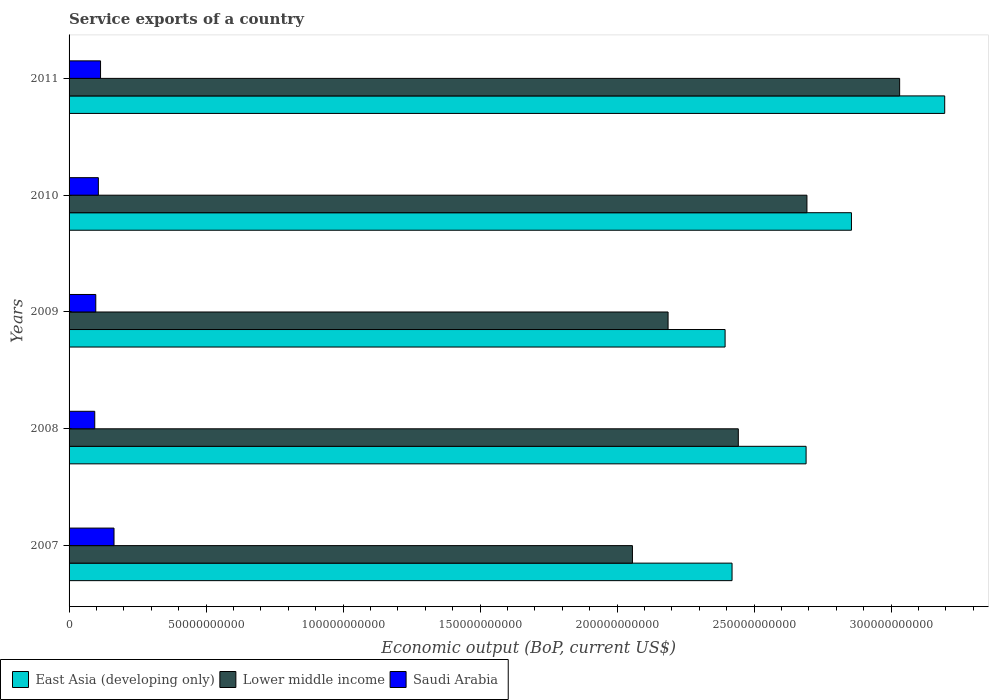How many different coloured bars are there?
Keep it short and to the point. 3. How many groups of bars are there?
Provide a succinct answer. 5. Are the number of bars per tick equal to the number of legend labels?
Offer a very short reply. Yes. How many bars are there on the 2nd tick from the top?
Your answer should be very brief. 3. How many bars are there on the 5th tick from the bottom?
Ensure brevity in your answer.  3. In how many cases, is the number of bars for a given year not equal to the number of legend labels?
Make the answer very short. 0. What is the service exports in East Asia (developing only) in 2008?
Make the answer very short. 2.69e+11. Across all years, what is the maximum service exports in Saudi Arabia?
Offer a very short reply. 1.64e+1. Across all years, what is the minimum service exports in Lower middle income?
Provide a short and direct response. 2.06e+11. In which year was the service exports in Lower middle income maximum?
Offer a very short reply. 2011. In which year was the service exports in Lower middle income minimum?
Your response must be concise. 2007. What is the total service exports in Lower middle income in the graph?
Offer a terse response. 1.24e+12. What is the difference between the service exports in East Asia (developing only) in 2008 and that in 2010?
Your answer should be very brief. -1.66e+1. What is the difference between the service exports in Saudi Arabia in 2008 and the service exports in East Asia (developing only) in 2007?
Make the answer very short. -2.33e+11. What is the average service exports in East Asia (developing only) per year?
Provide a succinct answer. 2.71e+11. In the year 2009, what is the difference between the service exports in East Asia (developing only) and service exports in Lower middle income?
Make the answer very short. 2.08e+1. In how many years, is the service exports in East Asia (developing only) greater than 300000000000 US$?
Keep it short and to the point. 1. What is the ratio of the service exports in Saudi Arabia in 2010 to that in 2011?
Your answer should be compact. 0.93. Is the service exports in East Asia (developing only) in 2007 less than that in 2010?
Your answer should be compact. Yes. What is the difference between the highest and the second highest service exports in East Asia (developing only)?
Offer a terse response. 3.40e+1. What is the difference between the highest and the lowest service exports in East Asia (developing only)?
Provide a short and direct response. 8.02e+1. What does the 3rd bar from the top in 2008 represents?
Provide a short and direct response. East Asia (developing only). What does the 1st bar from the bottom in 2008 represents?
Your response must be concise. East Asia (developing only). Is it the case that in every year, the sum of the service exports in Saudi Arabia and service exports in Lower middle income is greater than the service exports in East Asia (developing only)?
Give a very brief answer. No. How many bars are there?
Give a very brief answer. 15. How many years are there in the graph?
Provide a short and direct response. 5. Does the graph contain any zero values?
Give a very brief answer. No. Does the graph contain grids?
Your answer should be compact. No. Where does the legend appear in the graph?
Offer a very short reply. Bottom left. How are the legend labels stacked?
Keep it short and to the point. Horizontal. What is the title of the graph?
Provide a succinct answer. Service exports of a country. Does "Peru" appear as one of the legend labels in the graph?
Make the answer very short. No. What is the label or title of the X-axis?
Your answer should be very brief. Economic output (BoP, current US$). What is the label or title of the Y-axis?
Ensure brevity in your answer.  Years. What is the Economic output (BoP, current US$) in East Asia (developing only) in 2007?
Ensure brevity in your answer.  2.42e+11. What is the Economic output (BoP, current US$) of Lower middle income in 2007?
Ensure brevity in your answer.  2.06e+11. What is the Economic output (BoP, current US$) in Saudi Arabia in 2007?
Provide a short and direct response. 1.64e+1. What is the Economic output (BoP, current US$) in East Asia (developing only) in 2008?
Make the answer very short. 2.69e+11. What is the Economic output (BoP, current US$) in Lower middle income in 2008?
Your answer should be very brief. 2.44e+11. What is the Economic output (BoP, current US$) of Saudi Arabia in 2008?
Make the answer very short. 9.37e+09. What is the Economic output (BoP, current US$) of East Asia (developing only) in 2009?
Make the answer very short. 2.39e+11. What is the Economic output (BoP, current US$) of Lower middle income in 2009?
Ensure brevity in your answer.  2.19e+11. What is the Economic output (BoP, current US$) of Saudi Arabia in 2009?
Offer a very short reply. 9.75e+09. What is the Economic output (BoP, current US$) of East Asia (developing only) in 2010?
Ensure brevity in your answer.  2.86e+11. What is the Economic output (BoP, current US$) of Lower middle income in 2010?
Your response must be concise. 2.69e+11. What is the Economic output (BoP, current US$) in Saudi Arabia in 2010?
Ensure brevity in your answer.  1.07e+1. What is the Economic output (BoP, current US$) of East Asia (developing only) in 2011?
Offer a very short reply. 3.20e+11. What is the Economic output (BoP, current US$) of Lower middle income in 2011?
Give a very brief answer. 3.03e+11. What is the Economic output (BoP, current US$) of Saudi Arabia in 2011?
Offer a terse response. 1.15e+1. Across all years, what is the maximum Economic output (BoP, current US$) of East Asia (developing only)?
Ensure brevity in your answer.  3.20e+11. Across all years, what is the maximum Economic output (BoP, current US$) in Lower middle income?
Offer a very short reply. 3.03e+11. Across all years, what is the maximum Economic output (BoP, current US$) of Saudi Arabia?
Ensure brevity in your answer.  1.64e+1. Across all years, what is the minimum Economic output (BoP, current US$) of East Asia (developing only)?
Your answer should be very brief. 2.39e+11. Across all years, what is the minimum Economic output (BoP, current US$) in Lower middle income?
Keep it short and to the point. 2.06e+11. Across all years, what is the minimum Economic output (BoP, current US$) of Saudi Arabia?
Keep it short and to the point. 9.37e+09. What is the total Economic output (BoP, current US$) of East Asia (developing only) in the graph?
Provide a succinct answer. 1.36e+12. What is the total Economic output (BoP, current US$) of Lower middle income in the graph?
Keep it short and to the point. 1.24e+12. What is the total Economic output (BoP, current US$) of Saudi Arabia in the graph?
Provide a succinct answer. 5.77e+1. What is the difference between the Economic output (BoP, current US$) in East Asia (developing only) in 2007 and that in 2008?
Your answer should be very brief. -2.70e+1. What is the difference between the Economic output (BoP, current US$) in Lower middle income in 2007 and that in 2008?
Offer a very short reply. -3.86e+1. What is the difference between the Economic output (BoP, current US$) in Saudi Arabia in 2007 and that in 2008?
Your response must be concise. 7.03e+09. What is the difference between the Economic output (BoP, current US$) in East Asia (developing only) in 2007 and that in 2009?
Offer a very short reply. 2.54e+09. What is the difference between the Economic output (BoP, current US$) of Lower middle income in 2007 and that in 2009?
Ensure brevity in your answer.  -1.30e+1. What is the difference between the Economic output (BoP, current US$) in Saudi Arabia in 2007 and that in 2009?
Offer a very short reply. 6.65e+09. What is the difference between the Economic output (BoP, current US$) of East Asia (developing only) in 2007 and that in 2010?
Make the answer very short. -4.36e+1. What is the difference between the Economic output (BoP, current US$) in Lower middle income in 2007 and that in 2010?
Provide a succinct answer. -6.37e+1. What is the difference between the Economic output (BoP, current US$) in Saudi Arabia in 2007 and that in 2010?
Offer a very short reply. 5.72e+09. What is the difference between the Economic output (BoP, current US$) of East Asia (developing only) in 2007 and that in 2011?
Your response must be concise. -7.76e+1. What is the difference between the Economic output (BoP, current US$) of Lower middle income in 2007 and that in 2011?
Give a very brief answer. -9.75e+1. What is the difference between the Economic output (BoP, current US$) of Saudi Arabia in 2007 and that in 2011?
Offer a very short reply. 4.91e+09. What is the difference between the Economic output (BoP, current US$) of East Asia (developing only) in 2008 and that in 2009?
Your answer should be very brief. 2.96e+1. What is the difference between the Economic output (BoP, current US$) of Lower middle income in 2008 and that in 2009?
Provide a succinct answer. 2.56e+1. What is the difference between the Economic output (BoP, current US$) in Saudi Arabia in 2008 and that in 2009?
Provide a short and direct response. -3.76e+08. What is the difference between the Economic output (BoP, current US$) of East Asia (developing only) in 2008 and that in 2010?
Ensure brevity in your answer.  -1.66e+1. What is the difference between the Economic output (BoP, current US$) in Lower middle income in 2008 and that in 2010?
Provide a succinct answer. -2.50e+1. What is the difference between the Economic output (BoP, current US$) of Saudi Arabia in 2008 and that in 2010?
Provide a succinct answer. -1.32e+09. What is the difference between the Economic output (BoP, current US$) of East Asia (developing only) in 2008 and that in 2011?
Keep it short and to the point. -5.06e+1. What is the difference between the Economic output (BoP, current US$) of Lower middle income in 2008 and that in 2011?
Make the answer very short. -5.89e+1. What is the difference between the Economic output (BoP, current US$) in Saudi Arabia in 2008 and that in 2011?
Your answer should be compact. -2.12e+09. What is the difference between the Economic output (BoP, current US$) in East Asia (developing only) in 2009 and that in 2010?
Your answer should be very brief. -4.61e+1. What is the difference between the Economic output (BoP, current US$) in Lower middle income in 2009 and that in 2010?
Make the answer very short. -5.07e+1. What is the difference between the Economic output (BoP, current US$) in Saudi Arabia in 2009 and that in 2010?
Give a very brief answer. -9.39e+08. What is the difference between the Economic output (BoP, current US$) of East Asia (developing only) in 2009 and that in 2011?
Provide a short and direct response. -8.02e+1. What is the difference between the Economic output (BoP, current US$) of Lower middle income in 2009 and that in 2011?
Keep it short and to the point. -8.45e+1. What is the difference between the Economic output (BoP, current US$) of Saudi Arabia in 2009 and that in 2011?
Give a very brief answer. -1.74e+09. What is the difference between the Economic output (BoP, current US$) in East Asia (developing only) in 2010 and that in 2011?
Your response must be concise. -3.40e+1. What is the difference between the Economic output (BoP, current US$) in Lower middle income in 2010 and that in 2011?
Offer a very short reply. -3.38e+1. What is the difference between the Economic output (BoP, current US$) of Saudi Arabia in 2010 and that in 2011?
Ensure brevity in your answer.  -8.00e+08. What is the difference between the Economic output (BoP, current US$) in East Asia (developing only) in 2007 and the Economic output (BoP, current US$) in Lower middle income in 2008?
Offer a very short reply. -2.29e+09. What is the difference between the Economic output (BoP, current US$) of East Asia (developing only) in 2007 and the Economic output (BoP, current US$) of Saudi Arabia in 2008?
Ensure brevity in your answer.  2.33e+11. What is the difference between the Economic output (BoP, current US$) in Lower middle income in 2007 and the Economic output (BoP, current US$) in Saudi Arabia in 2008?
Offer a terse response. 1.96e+11. What is the difference between the Economic output (BoP, current US$) of East Asia (developing only) in 2007 and the Economic output (BoP, current US$) of Lower middle income in 2009?
Make the answer very short. 2.34e+1. What is the difference between the Economic output (BoP, current US$) in East Asia (developing only) in 2007 and the Economic output (BoP, current US$) in Saudi Arabia in 2009?
Offer a terse response. 2.32e+11. What is the difference between the Economic output (BoP, current US$) in Lower middle income in 2007 and the Economic output (BoP, current US$) in Saudi Arabia in 2009?
Your answer should be compact. 1.96e+11. What is the difference between the Economic output (BoP, current US$) in East Asia (developing only) in 2007 and the Economic output (BoP, current US$) in Lower middle income in 2010?
Your answer should be very brief. -2.73e+1. What is the difference between the Economic output (BoP, current US$) of East Asia (developing only) in 2007 and the Economic output (BoP, current US$) of Saudi Arabia in 2010?
Give a very brief answer. 2.31e+11. What is the difference between the Economic output (BoP, current US$) of Lower middle income in 2007 and the Economic output (BoP, current US$) of Saudi Arabia in 2010?
Ensure brevity in your answer.  1.95e+11. What is the difference between the Economic output (BoP, current US$) in East Asia (developing only) in 2007 and the Economic output (BoP, current US$) in Lower middle income in 2011?
Offer a terse response. -6.12e+1. What is the difference between the Economic output (BoP, current US$) in East Asia (developing only) in 2007 and the Economic output (BoP, current US$) in Saudi Arabia in 2011?
Keep it short and to the point. 2.30e+11. What is the difference between the Economic output (BoP, current US$) of Lower middle income in 2007 and the Economic output (BoP, current US$) of Saudi Arabia in 2011?
Provide a short and direct response. 1.94e+11. What is the difference between the Economic output (BoP, current US$) in East Asia (developing only) in 2008 and the Economic output (BoP, current US$) in Lower middle income in 2009?
Provide a succinct answer. 5.04e+1. What is the difference between the Economic output (BoP, current US$) of East Asia (developing only) in 2008 and the Economic output (BoP, current US$) of Saudi Arabia in 2009?
Make the answer very short. 2.59e+11. What is the difference between the Economic output (BoP, current US$) of Lower middle income in 2008 and the Economic output (BoP, current US$) of Saudi Arabia in 2009?
Your response must be concise. 2.35e+11. What is the difference between the Economic output (BoP, current US$) of East Asia (developing only) in 2008 and the Economic output (BoP, current US$) of Lower middle income in 2010?
Your response must be concise. -3.09e+08. What is the difference between the Economic output (BoP, current US$) of East Asia (developing only) in 2008 and the Economic output (BoP, current US$) of Saudi Arabia in 2010?
Keep it short and to the point. 2.58e+11. What is the difference between the Economic output (BoP, current US$) in Lower middle income in 2008 and the Economic output (BoP, current US$) in Saudi Arabia in 2010?
Provide a short and direct response. 2.34e+11. What is the difference between the Economic output (BoP, current US$) of East Asia (developing only) in 2008 and the Economic output (BoP, current US$) of Lower middle income in 2011?
Offer a very short reply. -3.41e+1. What is the difference between the Economic output (BoP, current US$) of East Asia (developing only) in 2008 and the Economic output (BoP, current US$) of Saudi Arabia in 2011?
Keep it short and to the point. 2.58e+11. What is the difference between the Economic output (BoP, current US$) in Lower middle income in 2008 and the Economic output (BoP, current US$) in Saudi Arabia in 2011?
Your answer should be very brief. 2.33e+11. What is the difference between the Economic output (BoP, current US$) in East Asia (developing only) in 2009 and the Economic output (BoP, current US$) in Lower middle income in 2010?
Your answer should be compact. -2.99e+1. What is the difference between the Economic output (BoP, current US$) of East Asia (developing only) in 2009 and the Economic output (BoP, current US$) of Saudi Arabia in 2010?
Offer a terse response. 2.29e+11. What is the difference between the Economic output (BoP, current US$) in Lower middle income in 2009 and the Economic output (BoP, current US$) in Saudi Arabia in 2010?
Give a very brief answer. 2.08e+11. What is the difference between the Economic output (BoP, current US$) of East Asia (developing only) in 2009 and the Economic output (BoP, current US$) of Lower middle income in 2011?
Your answer should be compact. -6.37e+1. What is the difference between the Economic output (BoP, current US$) of East Asia (developing only) in 2009 and the Economic output (BoP, current US$) of Saudi Arabia in 2011?
Your answer should be very brief. 2.28e+11. What is the difference between the Economic output (BoP, current US$) of Lower middle income in 2009 and the Economic output (BoP, current US$) of Saudi Arabia in 2011?
Your response must be concise. 2.07e+11. What is the difference between the Economic output (BoP, current US$) of East Asia (developing only) in 2010 and the Economic output (BoP, current US$) of Lower middle income in 2011?
Provide a succinct answer. -1.76e+1. What is the difference between the Economic output (BoP, current US$) of East Asia (developing only) in 2010 and the Economic output (BoP, current US$) of Saudi Arabia in 2011?
Make the answer very short. 2.74e+11. What is the difference between the Economic output (BoP, current US$) of Lower middle income in 2010 and the Economic output (BoP, current US$) of Saudi Arabia in 2011?
Your answer should be very brief. 2.58e+11. What is the average Economic output (BoP, current US$) of East Asia (developing only) per year?
Your answer should be very brief. 2.71e+11. What is the average Economic output (BoP, current US$) of Lower middle income per year?
Offer a terse response. 2.48e+11. What is the average Economic output (BoP, current US$) in Saudi Arabia per year?
Your response must be concise. 1.15e+1. In the year 2007, what is the difference between the Economic output (BoP, current US$) in East Asia (developing only) and Economic output (BoP, current US$) in Lower middle income?
Provide a succinct answer. 3.64e+1. In the year 2007, what is the difference between the Economic output (BoP, current US$) in East Asia (developing only) and Economic output (BoP, current US$) in Saudi Arabia?
Keep it short and to the point. 2.26e+11. In the year 2007, what is the difference between the Economic output (BoP, current US$) of Lower middle income and Economic output (BoP, current US$) of Saudi Arabia?
Ensure brevity in your answer.  1.89e+11. In the year 2008, what is the difference between the Economic output (BoP, current US$) of East Asia (developing only) and Economic output (BoP, current US$) of Lower middle income?
Make the answer very short. 2.47e+1. In the year 2008, what is the difference between the Economic output (BoP, current US$) of East Asia (developing only) and Economic output (BoP, current US$) of Saudi Arabia?
Offer a terse response. 2.60e+11. In the year 2008, what is the difference between the Economic output (BoP, current US$) in Lower middle income and Economic output (BoP, current US$) in Saudi Arabia?
Provide a succinct answer. 2.35e+11. In the year 2009, what is the difference between the Economic output (BoP, current US$) in East Asia (developing only) and Economic output (BoP, current US$) in Lower middle income?
Ensure brevity in your answer.  2.08e+1. In the year 2009, what is the difference between the Economic output (BoP, current US$) of East Asia (developing only) and Economic output (BoP, current US$) of Saudi Arabia?
Your response must be concise. 2.30e+11. In the year 2009, what is the difference between the Economic output (BoP, current US$) of Lower middle income and Economic output (BoP, current US$) of Saudi Arabia?
Ensure brevity in your answer.  2.09e+11. In the year 2010, what is the difference between the Economic output (BoP, current US$) of East Asia (developing only) and Economic output (BoP, current US$) of Lower middle income?
Give a very brief answer. 1.62e+1. In the year 2010, what is the difference between the Economic output (BoP, current US$) of East Asia (developing only) and Economic output (BoP, current US$) of Saudi Arabia?
Your answer should be very brief. 2.75e+11. In the year 2010, what is the difference between the Economic output (BoP, current US$) in Lower middle income and Economic output (BoP, current US$) in Saudi Arabia?
Your response must be concise. 2.59e+11. In the year 2011, what is the difference between the Economic output (BoP, current US$) of East Asia (developing only) and Economic output (BoP, current US$) of Lower middle income?
Ensure brevity in your answer.  1.64e+1. In the year 2011, what is the difference between the Economic output (BoP, current US$) of East Asia (developing only) and Economic output (BoP, current US$) of Saudi Arabia?
Offer a very short reply. 3.08e+11. In the year 2011, what is the difference between the Economic output (BoP, current US$) in Lower middle income and Economic output (BoP, current US$) in Saudi Arabia?
Your response must be concise. 2.92e+11. What is the ratio of the Economic output (BoP, current US$) of East Asia (developing only) in 2007 to that in 2008?
Offer a terse response. 0.9. What is the ratio of the Economic output (BoP, current US$) in Lower middle income in 2007 to that in 2008?
Your response must be concise. 0.84. What is the ratio of the Economic output (BoP, current US$) of Saudi Arabia in 2007 to that in 2008?
Provide a succinct answer. 1.75. What is the ratio of the Economic output (BoP, current US$) in East Asia (developing only) in 2007 to that in 2009?
Your response must be concise. 1.01. What is the ratio of the Economic output (BoP, current US$) of Lower middle income in 2007 to that in 2009?
Your answer should be very brief. 0.94. What is the ratio of the Economic output (BoP, current US$) in Saudi Arabia in 2007 to that in 2009?
Offer a terse response. 1.68. What is the ratio of the Economic output (BoP, current US$) of East Asia (developing only) in 2007 to that in 2010?
Your answer should be very brief. 0.85. What is the ratio of the Economic output (BoP, current US$) of Lower middle income in 2007 to that in 2010?
Offer a very short reply. 0.76. What is the ratio of the Economic output (BoP, current US$) of Saudi Arabia in 2007 to that in 2010?
Ensure brevity in your answer.  1.53. What is the ratio of the Economic output (BoP, current US$) in East Asia (developing only) in 2007 to that in 2011?
Give a very brief answer. 0.76. What is the ratio of the Economic output (BoP, current US$) in Lower middle income in 2007 to that in 2011?
Make the answer very short. 0.68. What is the ratio of the Economic output (BoP, current US$) in Saudi Arabia in 2007 to that in 2011?
Your answer should be very brief. 1.43. What is the ratio of the Economic output (BoP, current US$) in East Asia (developing only) in 2008 to that in 2009?
Your answer should be compact. 1.12. What is the ratio of the Economic output (BoP, current US$) in Lower middle income in 2008 to that in 2009?
Keep it short and to the point. 1.12. What is the ratio of the Economic output (BoP, current US$) of Saudi Arabia in 2008 to that in 2009?
Make the answer very short. 0.96. What is the ratio of the Economic output (BoP, current US$) of East Asia (developing only) in 2008 to that in 2010?
Offer a very short reply. 0.94. What is the ratio of the Economic output (BoP, current US$) of Lower middle income in 2008 to that in 2010?
Provide a succinct answer. 0.91. What is the ratio of the Economic output (BoP, current US$) of Saudi Arabia in 2008 to that in 2010?
Your answer should be very brief. 0.88. What is the ratio of the Economic output (BoP, current US$) in East Asia (developing only) in 2008 to that in 2011?
Offer a very short reply. 0.84. What is the ratio of the Economic output (BoP, current US$) in Lower middle income in 2008 to that in 2011?
Offer a terse response. 0.81. What is the ratio of the Economic output (BoP, current US$) in Saudi Arabia in 2008 to that in 2011?
Keep it short and to the point. 0.82. What is the ratio of the Economic output (BoP, current US$) of East Asia (developing only) in 2009 to that in 2010?
Keep it short and to the point. 0.84. What is the ratio of the Economic output (BoP, current US$) of Lower middle income in 2009 to that in 2010?
Make the answer very short. 0.81. What is the ratio of the Economic output (BoP, current US$) in Saudi Arabia in 2009 to that in 2010?
Give a very brief answer. 0.91. What is the ratio of the Economic output (BoP, current US$) of East Asia (developing only) in 2009 to that in 2011?
Ensure brevity in your answer.  0.75. What is the ratio of the Economic output (BoP, current US$) in Lower middle income in 2009 to that in 2011?
Make the answer very short. 0.72. What is the ratio of the Economic output (BoP, current US$) in Saudi Arabia in 2009 to that in 2011?
Make the answer very short. 0.85. What is the ratio of the Economic output (BoP, current US$) of East Asia (developing only) in 2010 to that in 2011?
Give a very brief answer. 0.89. What is the ratio of the Economic output (BoP, current US$) in Lower middle income in 2010 to that in 2011?
Provide a succinct answer. 0.89. What is the ratio of the Economic output (BoP, current US$) in Saudi Arabia in 2010 to that in 2011?
Make the answer very short. 0.93. What is the difference between the highest and the second highest Economic output (BoP, current US$) of East Asia (developing only)?
Keep it short and to the point. 3.40e+1. What is the difference between the highest and the second highest Economic output (BoP, current US$) of Lower middle income?
Give a very brief answer. 3.38e+1. What is the difference between the highest and the second highest Economic output (BoP, current US$) in Saudi Arabia?
Provide a succinct answer. 4.91e+09. What is the difference between the highest and the lowest Economic output (BoP, current US$) in East Asia (developing only)?
Your answer should be compact. 8.02e+1. What is the difference between the highest and the lowest Economic output (BoP, current US$) in Lower middle income?
Your response must be concise. 9.75e+1. What is the difference between the highest and the lowest Economic output (BoP, current US$) of Saudi Arabia?
Your answer should be compact. 7.03e+09. 